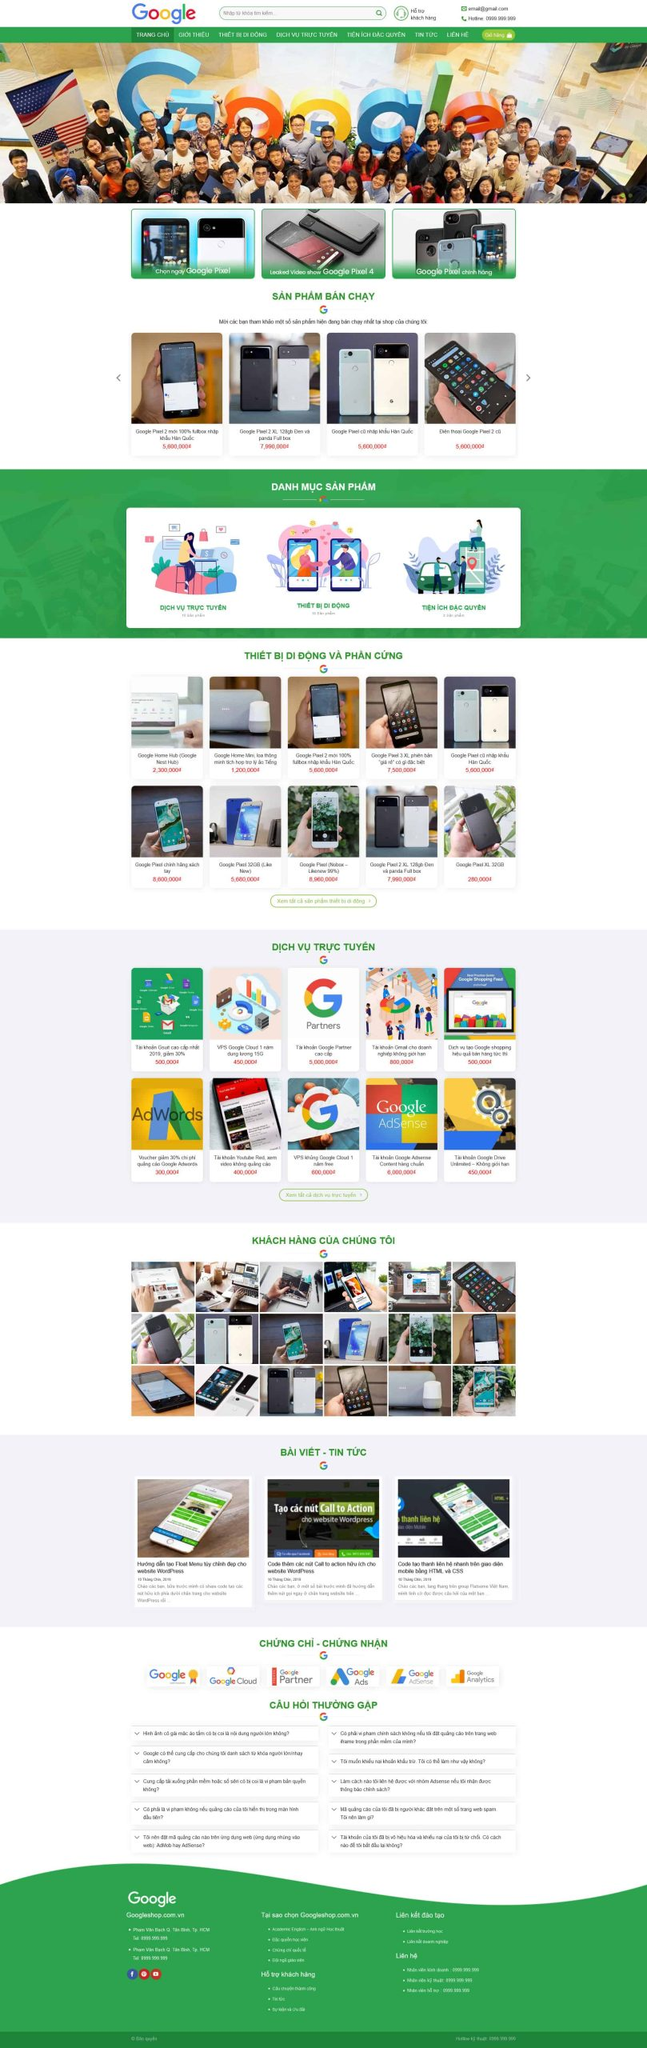Liệt kê 5 ngành nghề, lĩnh vực phù hợp với website này, phân cách các màu sắc bằng dấu phẩy. Chỉ trả về kết quả, phân cách bằng dấy phẩy
 Công nghệ thông tin, Thương mại điện tử, Dịch vụ trực tuyến, Thiết bị di động, Tiếp thị số 